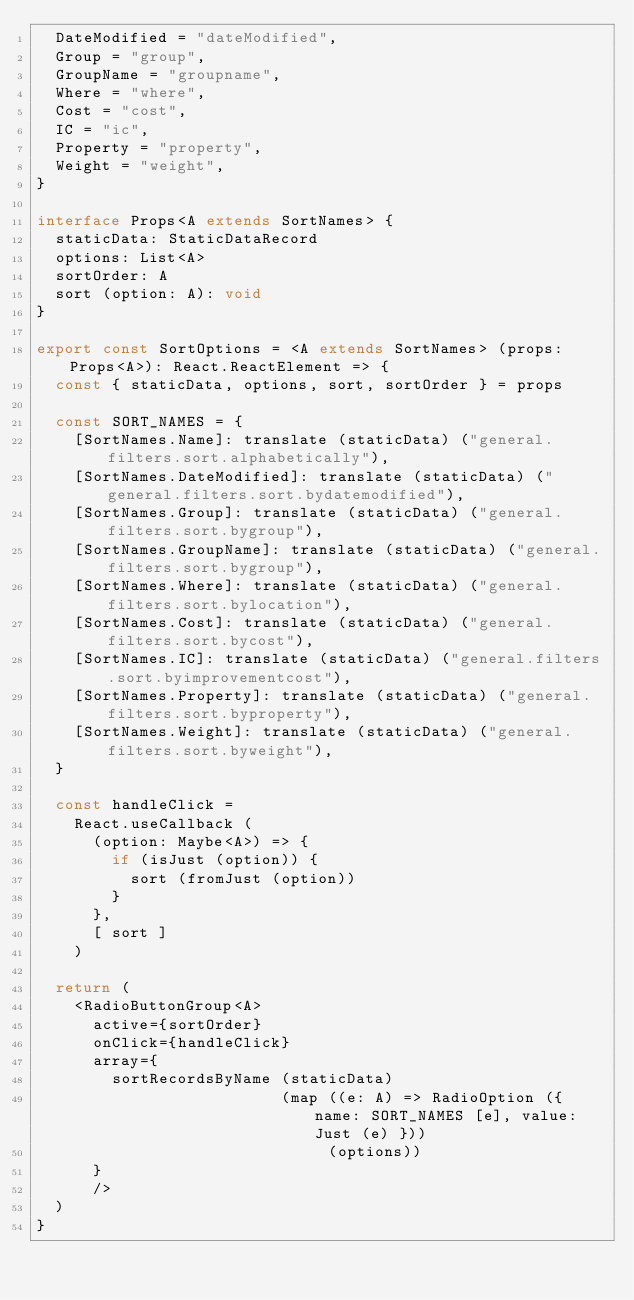Convert code to text. <code><loc_0><loc_0><loc_500><loc_500><_TypeScript_>  DateModified = "dateModified",
  Group = "group",
  GroupName = "groupname",
  Where = "where",
  Cost = "cost",
  IC = "ic",
  Property = "property",
  Weight = "weight",
}

interface Props<A extends SortNames> {
  staticData: StaticDataRecord
  options: List<A>
  sortOrder: A
  sort (option: A): void
}

export const SortOptions = <A extends SortNames> (props: Props<A>): React.ReactElement => {
  const { staticData, options, sort, sortOrder } = props

  const SORT_NAMES = {
    [SortNames.Name]: translate (staticData) ("general.filters.sort.alphabetically"),
    [SortNames.DateModified]: translate (staticData) ("general.filters.sort.bydatemodified"),
    [SortNames.Group]: translate (staticData) ("general.filters.sort.bygroup"),
    [SortNames.GroupName]: translate (staticData) ("general.filters.sort.bygroup"),
    [SortNames.Where]: translate (staticData) ("general.filters.sort.bylocation"),
    [SortNames.Cost]: translate (staticData) ("general.filters.sort.bycost"),
    [SortNames.IC]: translate (staticData) ("general.filters.sort.byimprovementcost"),
    [SortNames.Property]: translate (staticData) ("general.filters.sort.byproperty"),
    [SortNames.Weight]: translate (staticData) ("general.filters.sort.byweight"),
  }

  const handleClick =
    React.useCallback (
      (option: Maybe<A>) => {
        if (isJust (option)) {
          sort (fromJust (option))
        }
      },
      [ sort ]
    )

  return (
    <RadioButtonGroup<A>
      active={sortOrder}
      onClick={handleClick}
      array={
        sortRecordsByName (staticData)
                          (map ((e: A) => RadioOption ({ name: SORT_NAMES [e], value: Just (e) }))
                               (options))
      }
      />
  )
}
</code> 